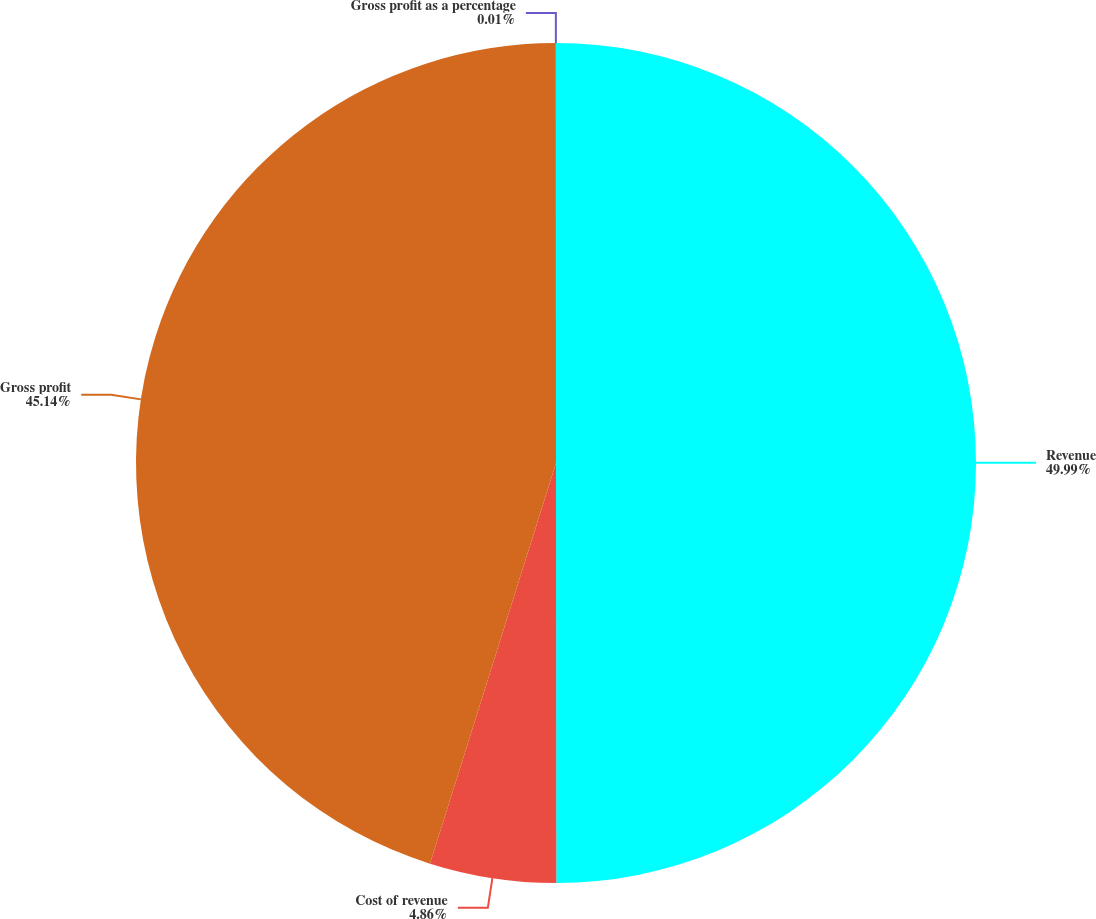Convert chart. <chart><loc_0><loc_0><loc_500><loc_500><pie_chart><fcel>Revenue<fcel>Cost of revenue<fcel>Gross profit<fcel>Gross profit as a percentage<nl><fcel>49.99%<fcel>4.86%<fcel>45.14%<fcel>0.01%<nl></chart> 